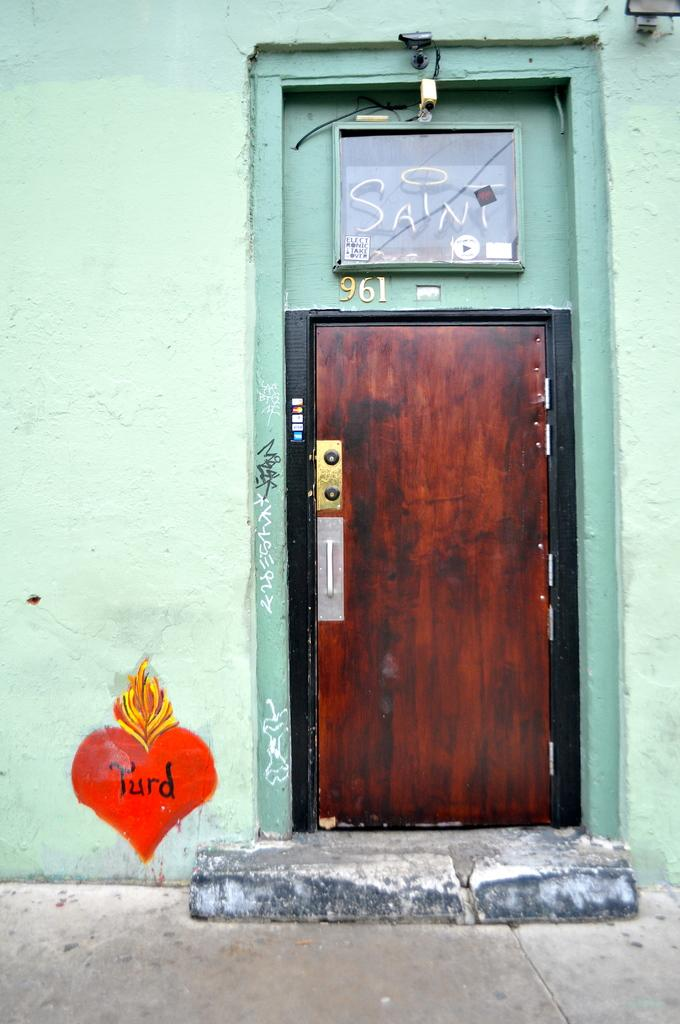What is the main object in the center of the picture? There is a door board in the center of the picture. What color is the wall surrounding the door board? The wall is painted green. Is there any source of light visible in the image? Yes, there is a light at the top of the image. What can be seen in the foreground of the image? In the foreground, there are pavement and steps. What type of mint is growing near the door board in the image? There is no mint visible in the image; the focus is on the door board, wall, light, and foreground elements. 